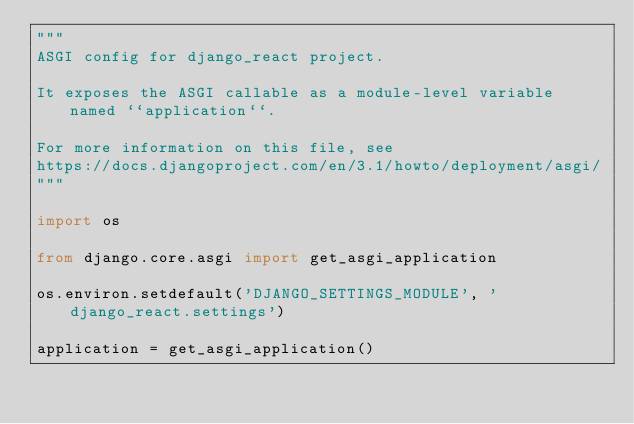<code> <loc_0><loc_0><loc_500><loc_500><_Python_>"""
ASGI config for django_react project.

It exposes the ASGI callable as a module-level variable named ``application``.

For more information on this file, see
https://docs.djangoproject.com/en/3.1/howto/deployment/asgi/
"""

import os

from django.core.asgi import get_asgi_application

os.environ.setdefault('DJANGO_SETTINGS_MODULE', 'django_react.settings')

application = get_asgi_application()
</code> 